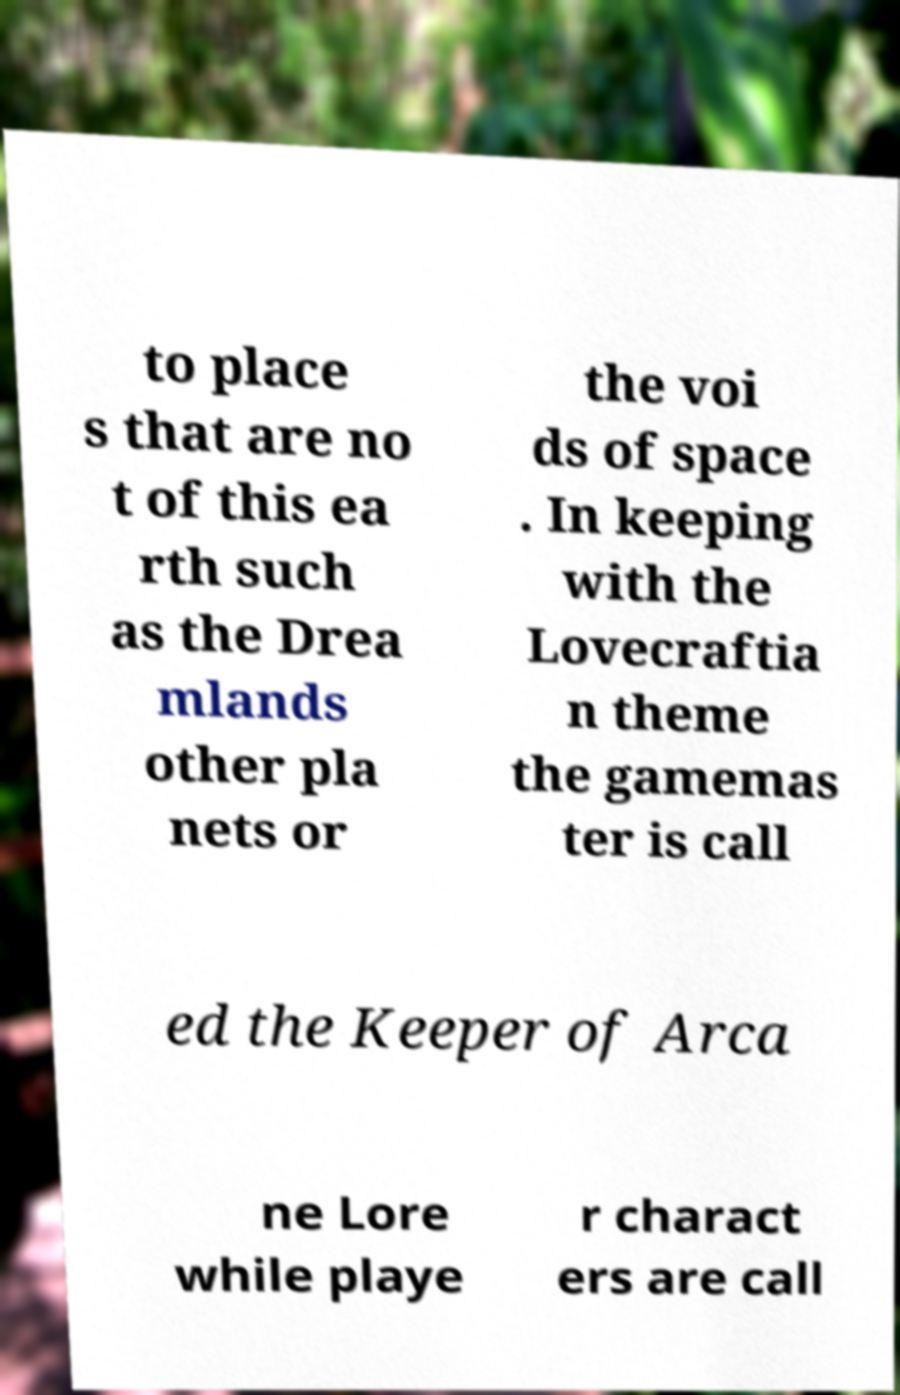Can you accurately transcribe the text from the provided image for me? to place s that are no t of this ea rth such as the Drea mlands other pla nets or the voi ds of space . In keeping with the Lovecraftia n theme the gamemas ter is call ed the Keeper of Arca ne Lore while playe r charact ers are call 